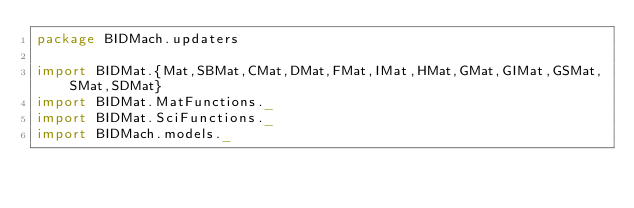Convert code to text. <code><loc_0><loc_0><loc_500><loc_500><_Scala_>package BIDMach.updaters

import BIDMat.{Mat,SBMat,CMat,DMat,FMat,IMat,HMat,GMat,GIMat,GSMat,SMat,SDMat}
import BIDMat.MatFunctions._
import BIDMat.SciFunctions._
import BIDMach.models._

</code> 